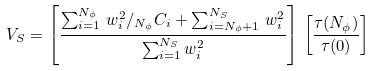<formula> <loc_0><loc_0><loc_500><loc_500>V _ { S } = \left [ \frac { \sum _ { i = 1 } ^ { N _ { \phi } } \, w ^ { 2 } _ { i } / _ { N _ { \phi } } C _ { i } + \sum _ { i = N _ { \phi } + 1 } ^ { N _ { S } } \, w ^ { 2 } _ { i } } { \sum _ { i = 1 } ^ { N _ { S } } w ^ { 2 } _ { i } } \right ] \, \left [ \frac { \tau ( N _ { \phi } ) } { \tau ( 0 ) } \right ]</formula> 